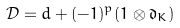Convert formula to latex. <formula><loc_0><loc_0><loc_500><loc_500>\mathcal { D } = d + ( - 1 ) ^ { p } ( 1 \otimes \mathfrak { d } _ { K } )</formula> 